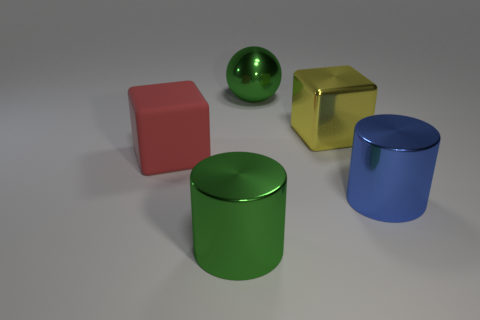Add 2 large metallic cylinders. How many objects exist? 7 Subtract 2 cubes. How many cubes are left? 0 Subtract all yellow blocks. How many cyan spheres are left? 0 Add 1 green metal objects. How many green metal objects exist? 3 Subtract all yellow cubes. How many cubes are left? 1 Subtract 0 red spheres. How many objects are left? 5 Subtract all balls. How many objects are left? 4 Subtract all purple cubes. Subtract all yellow cylinders. How many cubes are left? 2 Subtract all large cylinders. Subtract all tiny brown shiny blocks. How many objects are left? 3 Add 4 big green metal objects. How many big green metal objects are left? 6 